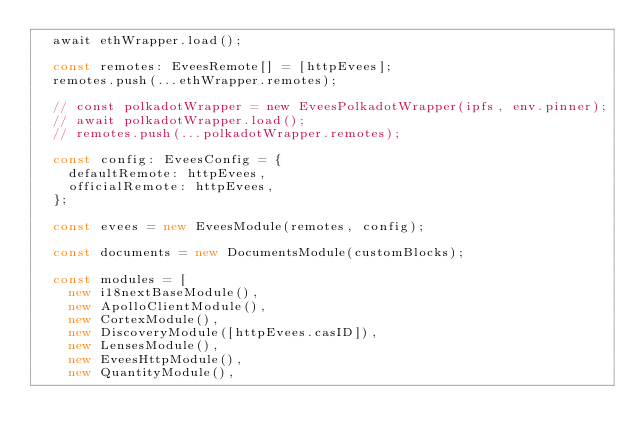<code> <loc_0><loc_0><loc_500><loc_500><_TypeScript_>  await ethWrapper.load();

  const remotes: EveesRemote[] = [httpEvees];
  remotes.push(...ethWrapper.remotes);

  // const polkadotWrapper = new EveesPolkadotWrapper(ipfs, env.pinner);
  // await polkadotWrapper.load();
  // remotes.push(...polkadotWrapper.remotes);

  const config: EveesConfig = {
    defaultRemote: httpEvees,
    officialRemote: httpEvees,
  };

  const evees = new EveesModule(remotes, config);

  const documents = new DocumentsModule(customBlocks);

  const modules = [
    new i18nextBaseModule(),
    new ApolloClientModule(),
    new CortexModule(),
    new DiscoveryModule([httpEvees.casID]),
    new LensesModule(),
    new EveesHttpModule(),
    new QuantityModule(),</code> 